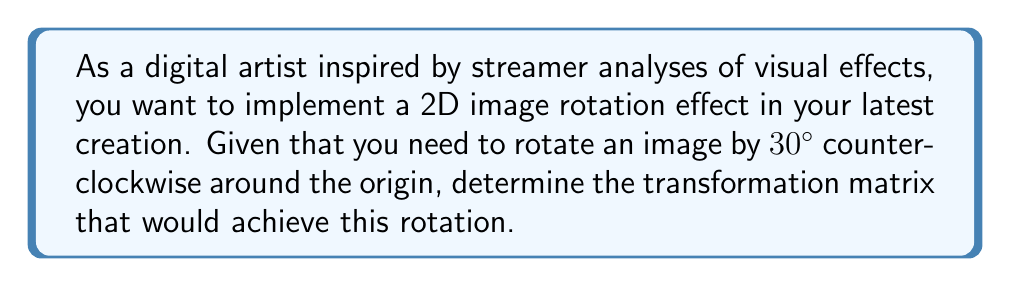Teach me how to tackle this problem. To determine the transformation matrix for a 2D image rotation effect, we need to use the general rotation matrix formula and plug in the specific angle of rotation.

1. The general 2D rotation matrix for a counterclockwise rotation by an angle θ is:

   $$R(\theta) = \begin{bmatrix} 
   \cos\theta & -\sin\theta \\
   \sin\theta & \cos\theta 
   \end{bmatrix}$$

2. In this case, we need to rotate by 30° counterclockwise. We need to convert this to radians:
   
   $30° = 30 \times \frac{\pi}{180} = \frac{\pi}{6}$ radians

3. Now, we can substitute $\theta = \frac{\pi}{6}$ into our rotation matrix:

   $$R(\frac{\pi}{6}) = \begin{bmatrix} 
   \cos(\frac{\pi}{6}) & -\sin(\frac{\pi}{6}) \\
   \sin(\frac{\pi}{6}) & \cos(\frac{\pi}{6}) 
   \end{bmatrix}$$

4. Let's calculate these trigonometric values:
   
   $\cos(\frac{\pi}{6}) = \frac{\sqrt{3}}{2}$
   
   $\sin(\frac{\pi}{6}) = \frac{1}{2}$

5. Substituting these values into our matrix:

   $$R(\frac{\pi}{6}) = \begin{bmatrix} 
   \frac{\sqrt{3}}{2} & -\frac{1}{2} \\
   \frac{1}{2} & \frac{\sqrt{3}}{2} 
   \end{bmatrix}$$

This matrix will rotate any point $(x, y)$ in your image by 30° counterclockwise around the origin when you multiply it by the column vector $\begin{bmatrix} x \\ y \end{bmatrix}$.
Answer: The transformation matrix for a 30° counterclockwise rotation is:

$$R(\frac{\pi}{6}) = \begin{bmatrix} 
\frac{\sqrt{3}}{2} & -\frac{1}{2} \\
\frac{1}{2} & \frac{\sqrt{3}}{2} 
\end{bmatrix}$$ 